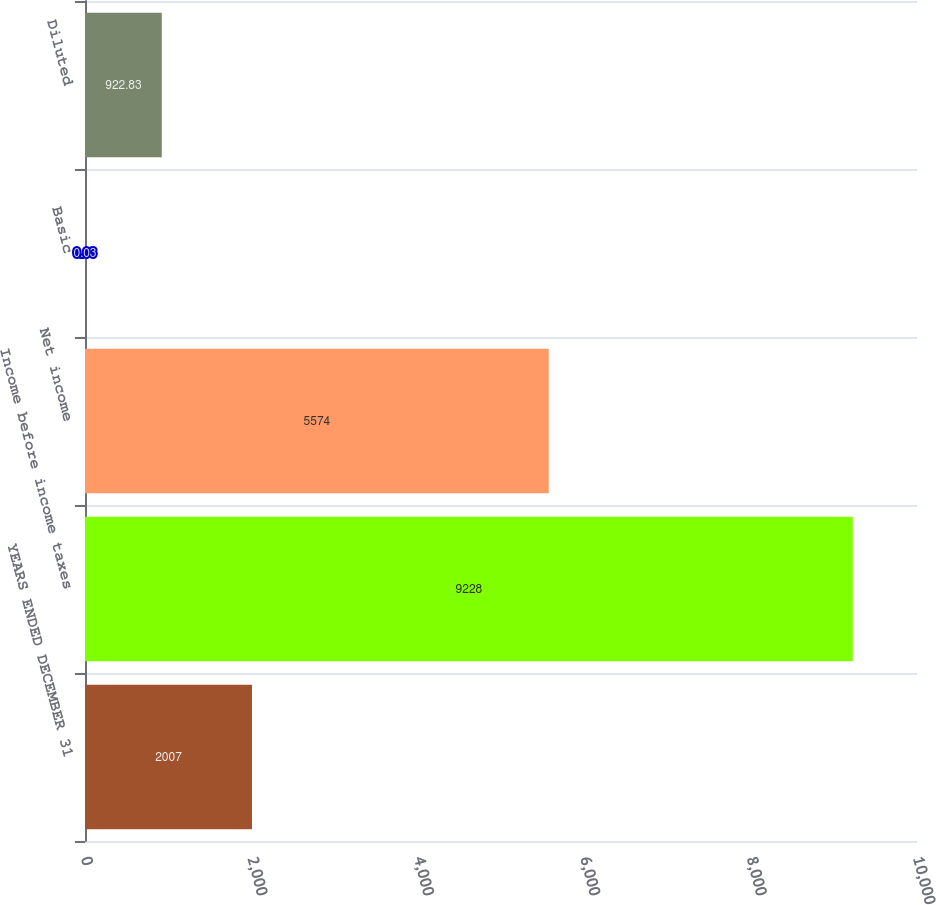Convert chart to OTSL. <chart><loc_0><loc_0><loc_500><loc_500><bar_chart><fcel>YEARS ENDED DECEMBER 31<fcel>Income before income taxes<fcel>Net income<fcel>Basic<fcel>Diluted<nl><fcel>2007<fcel>9228<fcel>5574<fcel>0.03<fcel>922.83<nl></chart> 